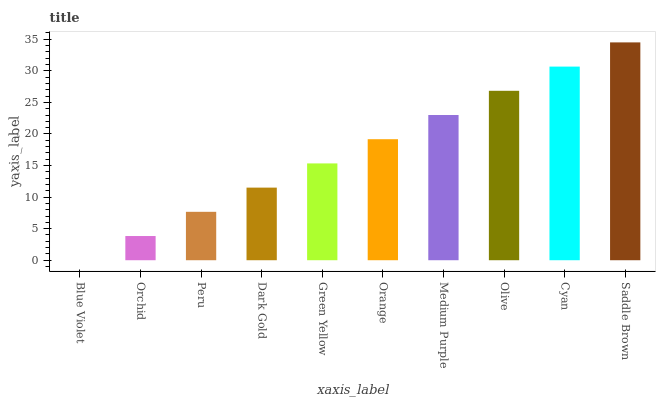Is Orchid the minimum?
Answer yes or no. No. Is Orchid the maximum?
Answer yes or no. No. Is Orchid greater than Blue Violet?
Answer yes or no. Yes. Is Blue Violet less than Orchid?
Answer yes or no. Yes. Is Blue Violet greater than Orchid?
Answer yes or no. No. Is Orchid less than Blue Violet?
Answer yes or no. No. Is Orange the high median?
Answer yes or no. Yes. Is Green Yellow the low median?
Answer yes or no. Yes. Is Blue Violet the high median?
Answer yes or no. No. Is Orange the low median?
Answer yes or no. No. 